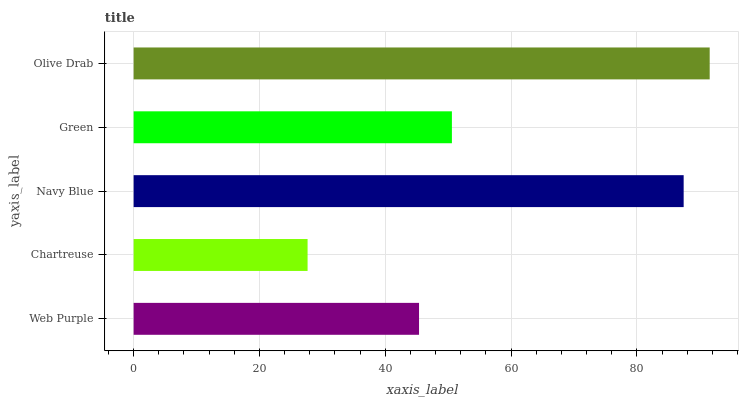Is Chartreuse the minimum?
Answer yes or no. Yes. Is Olive Drab the maximum?
Answer yes or no. Yes. Is Navy Blue the minimum?
Answer yes or no. No. Is Navy Blue the maximum?
Answer yes or no. No. Is Navy Blue greater than Chartreuse?
Answer yes or no. Yes. Is Chartreuse less than Navy Blue?
Answer yes or no. Yes. Is Chartreuse greater than Navy Blue?
Answer yes or no. No. Is Navy Blue less than Chartreuse?
Answer yes or no. No. Is Green the high median?
Answer yes or no. Yes. Is Green the low median?
Answer yes or no. Yes. Is Chartreuse the high median?
Answer yes or no. No. Is Web Purple the low median?
Answer yes or no. No. 